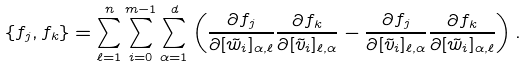Convert formula to latex. <formula><loc_0><loc_0><loc_500><loc_500>\{ f _ { j } , f _ { k } \} = \sum _ { \ell = 1 } ^ { n } \sum _ { i = 0 } ^ { m - 1 } \sum _ { \alpha = 1 } ^ { d } \left ( \frac { \partial f _ { j } } { \partial [ \tilde { w } _ { i } ] _ { \alpha , \ell } } \frac { \partial f _ { k } } { \partial [ \tilde { v } _ { i } ] _ { \ell , \alpha } } - \frac { \partial f _ { j } } { \partial [ \tilde { v } _ { i } ] _ { \ell , \alpha } } \frac { \partial f _ { k } } { \partial [ \tilde { w } _ { i } ] _ { \alpha , \ell } } \right ) .</formula> 